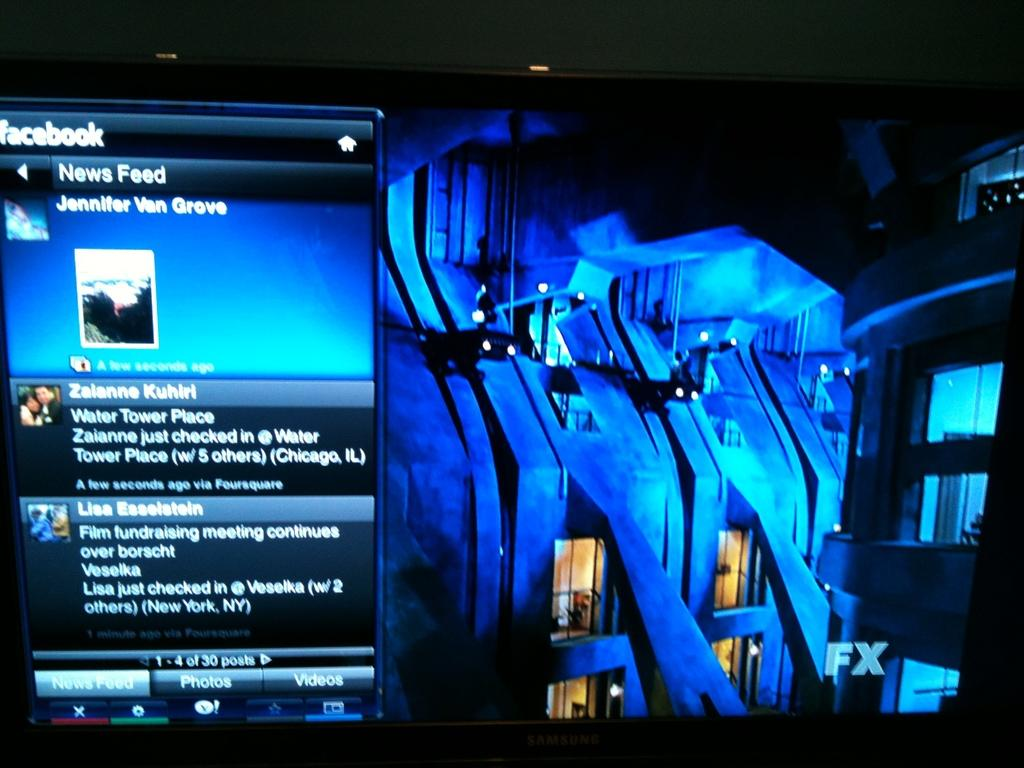<image>
Write a terse but informative summary of the picture. a zalanne character that is in a chat with others 